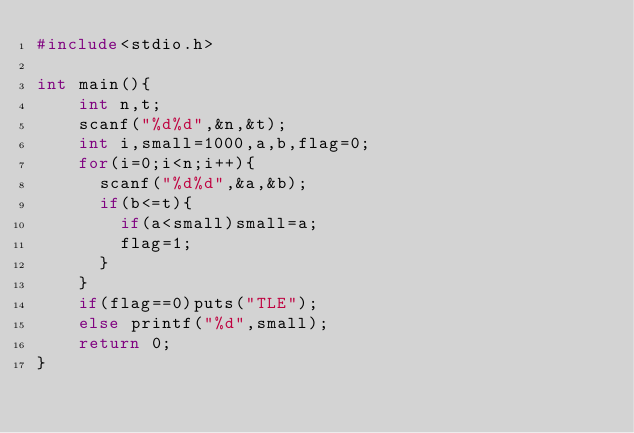Convert code to text. <code><loc_0><loc_0><loc_500><loc_500><_C_>#include<stdio.h>
 
int main(){
		int n,t;
		scanf("%d%d",&n,&t);
		int i,small=1000,a,b,flag=0;
		for(i=0;i<n;i++){
			scanf("%d%d",&a,&b);
			if(b<=t){
				if(a<small)small=a;
				flag=1;
			}
		}
		if(flag==0)puts("TLE");
		else printf("%d",small);
		return 0;
}</code> 